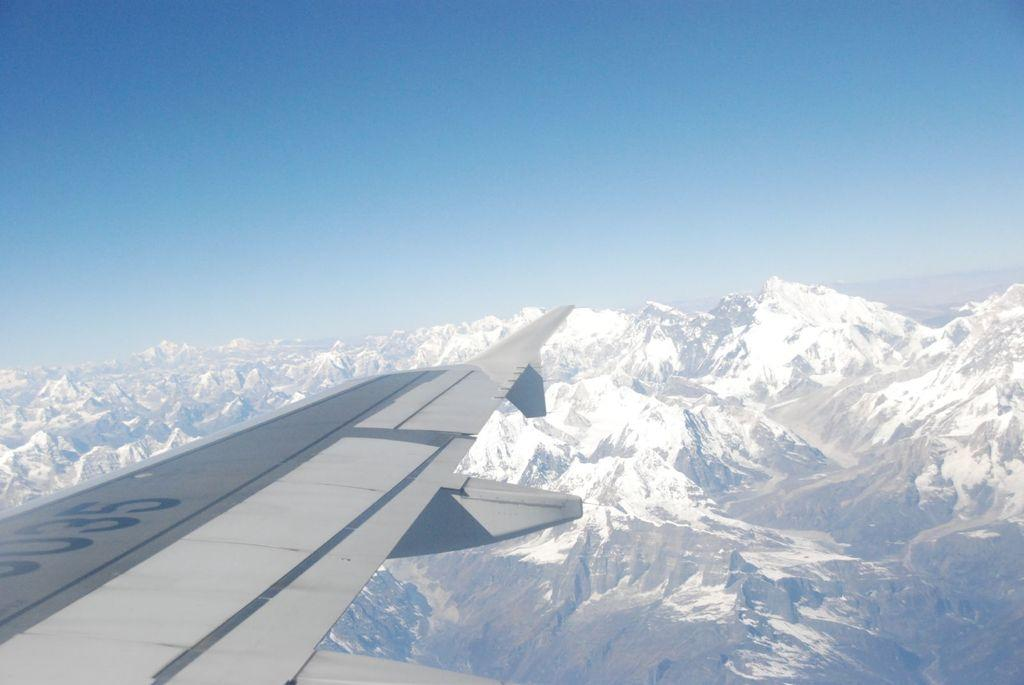<image>
Provide a brief description of the given image. An airplane is soaring above the snowy mountain peaks with 035 written on its wing 